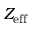<formula> <loc_0><loc_0><loc_500><loc_500>Z _ { e f f }</formula> 